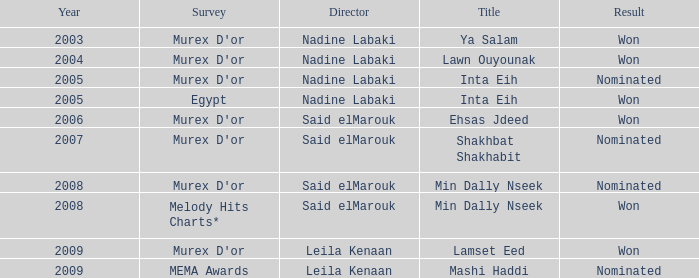What survey has the Ehsas Jdeed title? Murex D'or. 